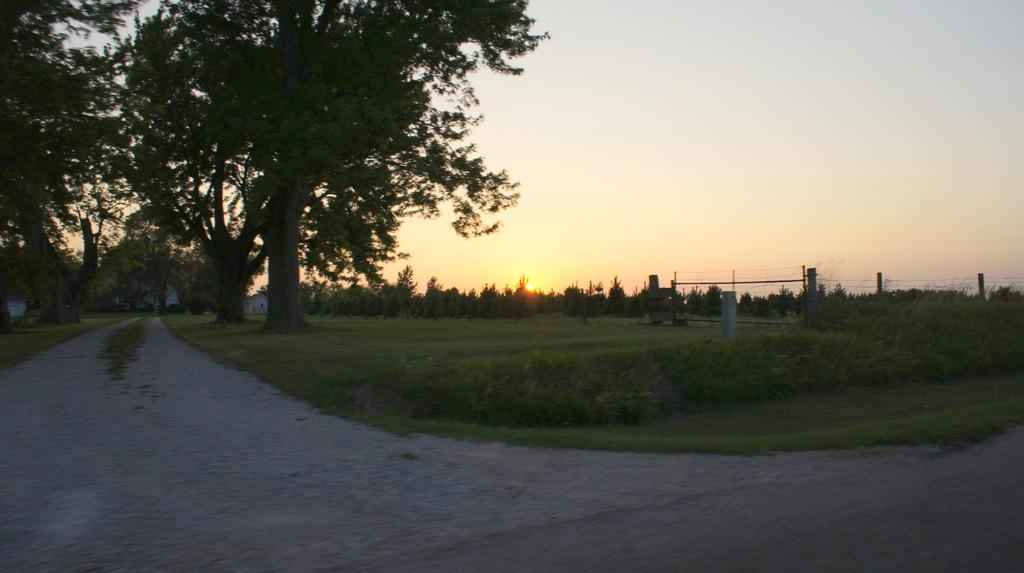What can be seen on the ground in the image? There are plants and grass on the ground in the image. What is the main feature of the image? The main feature of the image is a path. What can be seen in the background of the image? There are trees and the sky visible in the background of the image. What type of canvas is being used to create the worm in the image? There is no canvas or worm present in the image. How many pickles are visible on the path in the image? There are no pickles present in the image; it features a path, plants, grass, trees, and the sky. 